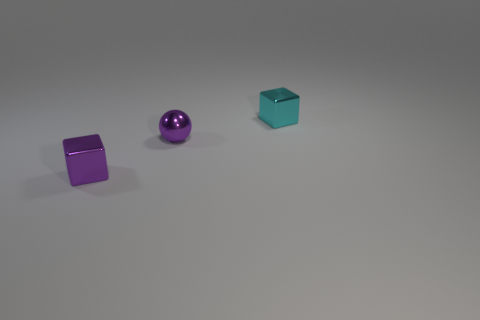Add 3 large purple metallic cylinders. How many objects exist? 6 Subtract all spheres. How many objects are left? 2 Subtract all small cyan metal blocks. Subtract all purple shiny objects. How many objects are left? 0 Add 3 tiny metal spheres. How many tiny metal spheres are left? 4 Add 3 large blue metal balls. How many large blue metal balls exist? 3 Subtract 0 brown blocks. How many objects are left? 3 